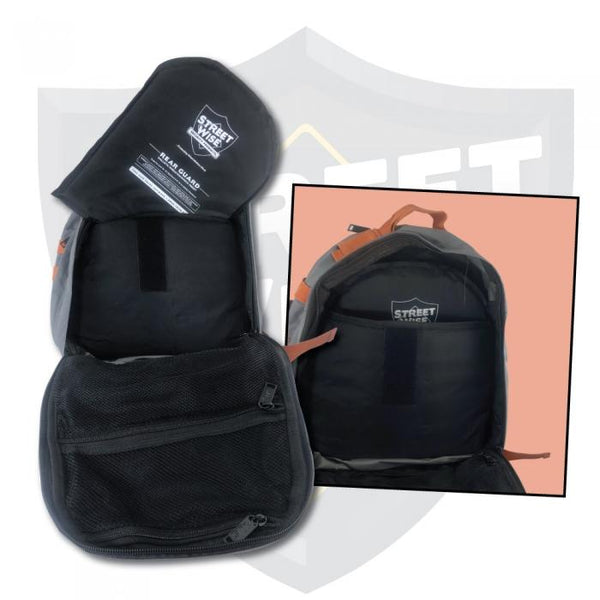What kind of maintenance or care would this backpack require to ensure longevity and functionality? To ensure the longevity and functionality of this backpack, regular maintenance is key. It's advisable to clean the backpack regularly, wiping down the outer surfaces with a damp cloth to remove dirt and grime. The mesh compartments should be checked frequently for any residual dampness and wiped dry to prevent mold and mildew. If the backpack has reflective elements, ensure they are free from obstructions and dirt to maintain their effectiveness in low-light conditions. Additionally, inspecting the zippers for smooth operation and applying zipper lubricants as needed can prolong their life. Storing the backpack in a cool, dry place when not in use is essential to prevent any damage from excessive moisture or heat. 